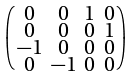Convert formula to latex. <formula><loc_0><loc_0><loc_500><loc_500>\begin{psmallmatrix} 0 & 0 & 1 & 0 \\ 0 & 0 & 0 & 1 \\ - 1 & 0 & 0 & 0 \\ 0 & - 1 & 0 & 0 \end{psmallmatrix}</formula> 